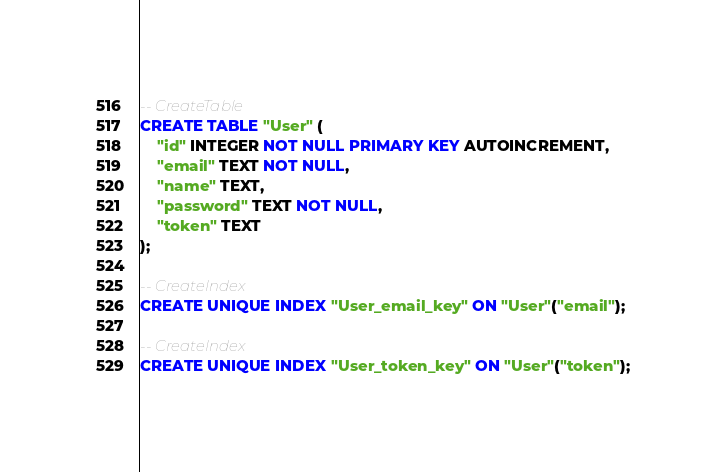Convert code to text. <code><loc_0><loc_0><loc_500><loc_500><_SQL_>-- CreateTable
CREATE TABLE "User" (
    "id" INTEGER NOT NULL PRIMARY KEY AUTOINCREMENT,
    "email" TEXT NOT NULL,
    "name" TEXT,
    "password" TEXT NOT NULL,
    "token" TEXT
);

-- CreateIndex
CREATE UNIQUE INDEX "User_email_key" ON "User"("email");

-- CreateIndex
CREATE UNIQUE INDEX "User_token_key" ON "User"("token");
</code> 